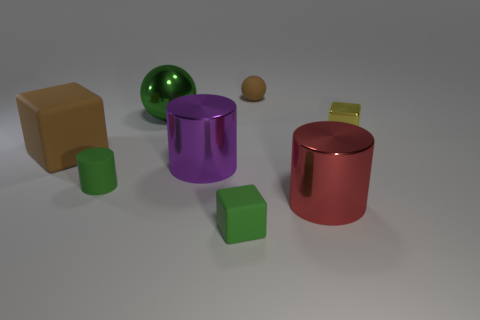Add 1 matte cylinders. How many objects exist? 9 Subtract all cylinders. How many objects are left? 5 Add 7 large cubes. How many large cubes are left? 8 Add 7 yellow metallic cubes. How many yellow metallic cubes exist? 8 Subtract 0 cyan blocks. How many objects are left? 8 Subtract all small yellow cubes. Subtract all large metal cylinders. How many objects are left? 5 